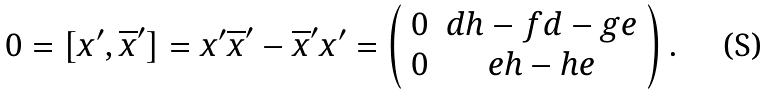Convert formula to latex. <formula><loc_0><loc_0><loc_500><loc_500>0 = [ x ^ { \prime } , \overline { x } ^ { \prime } ] = x ^ { \prime } \overline { x } ^ { \prime } - \overline { x } ^ { \prime } x ^ { \prime } = \left ( \begin{array} { c c } 0 & d h - f d - g e \\ 0 & e h - h e \\ \end{array} \right ) .</formula> 